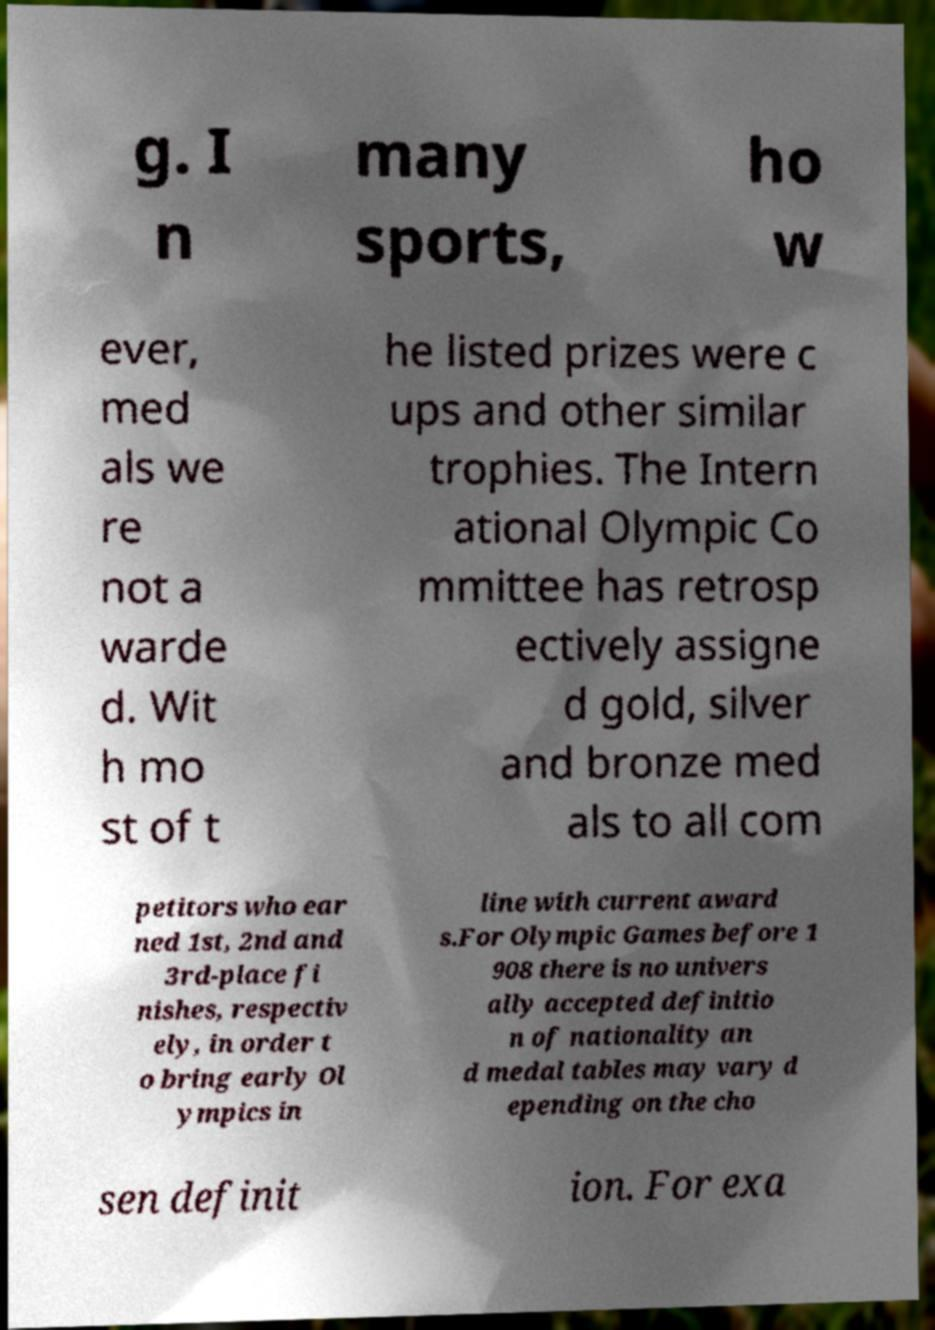I need the written content from this picture converted into text. Can you do that? g. I n many sports, ho w ever, med als we re not a warde d. Wit h mo st of t he listed prizes were c ups and other similar trophies. The Intern ational Olympic Co mmittee has retrosp ectively assigne d gold, silver and bronze med als to all com petitors who ear ned 1st, 2nd and 3rd-place fi nishes, respectiv ely, in order t o bring early Ol ympics in line with current award s.For Olympic Games before 1 908 there is no univers ally accepted definitio n of nationality an d medal tables may vary d epending on the cho sen definit ion. For exa 